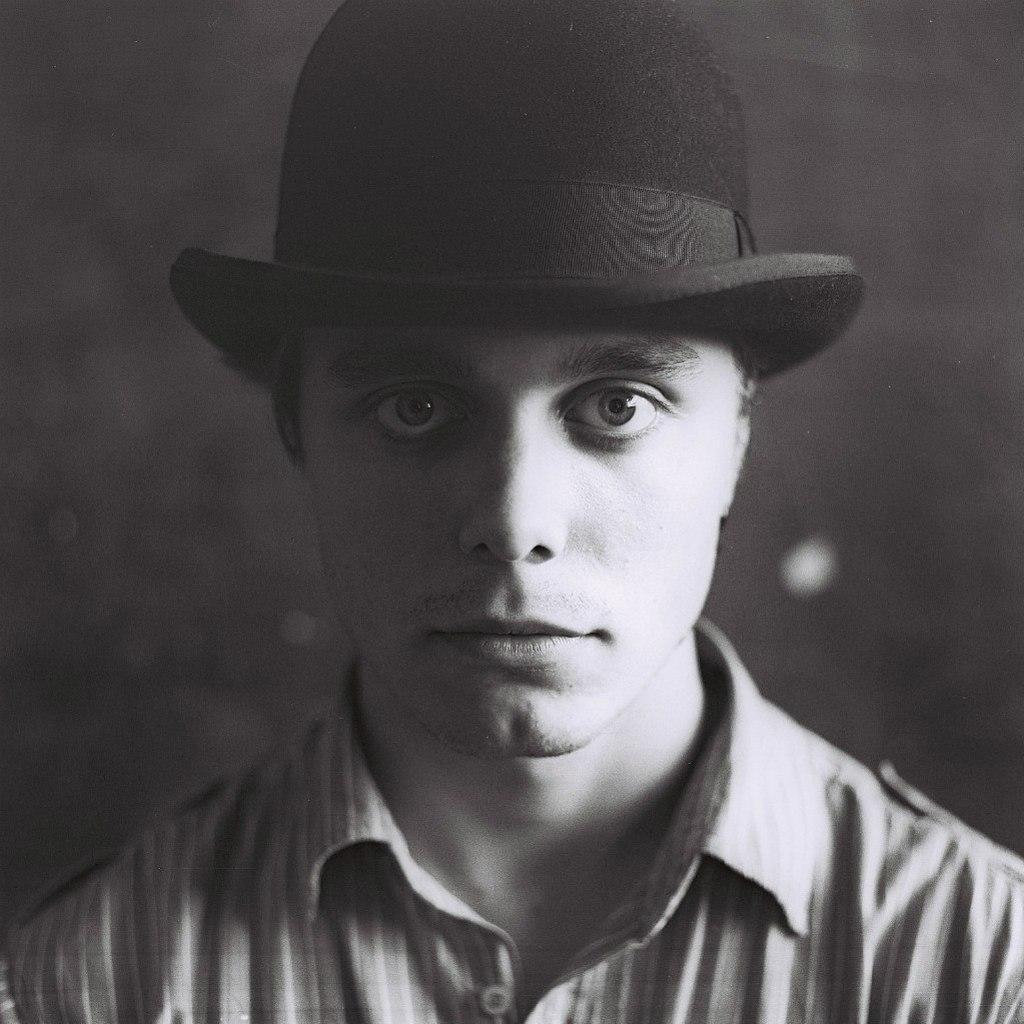How would you summarize this image in a sentence or two? This is a black and white image. In this image we can see persons face. 